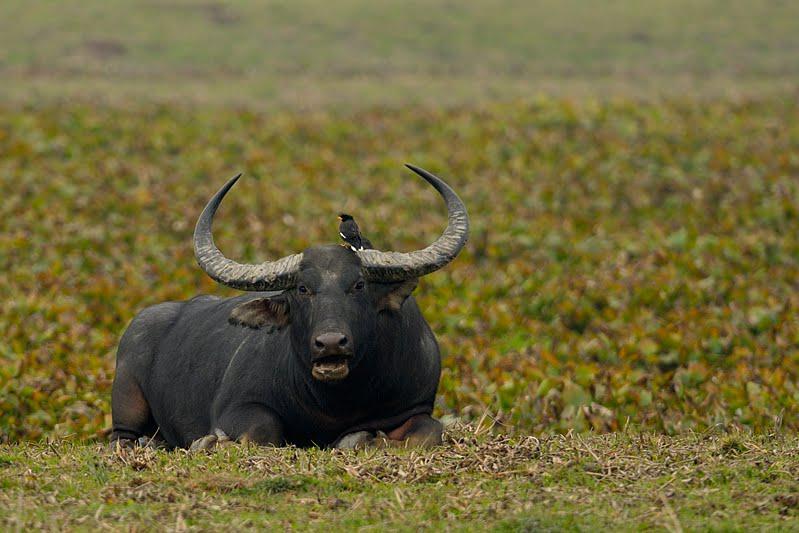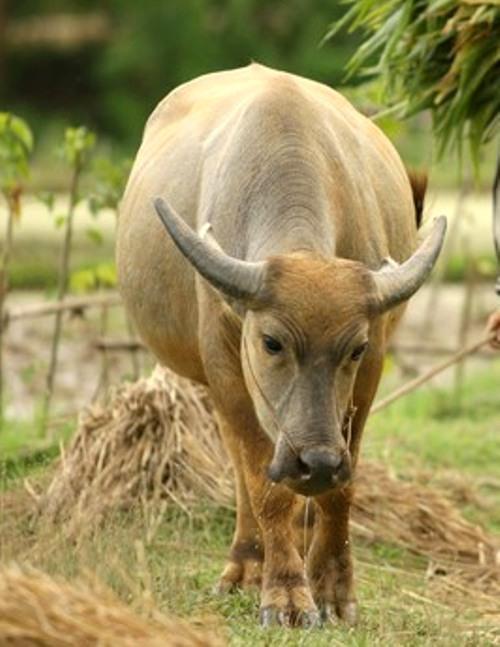The first image is the image on the left, the second image is the image on the right. Considering the images on both sides, is "There is only one bull facing left in the left image." valid? Answer yes or no. No. The first image is the image on the left, the second image is the image on the right. Considering the images on both sides, is "Both images have only one dark bull each." valid? Answer yes or no. No. 